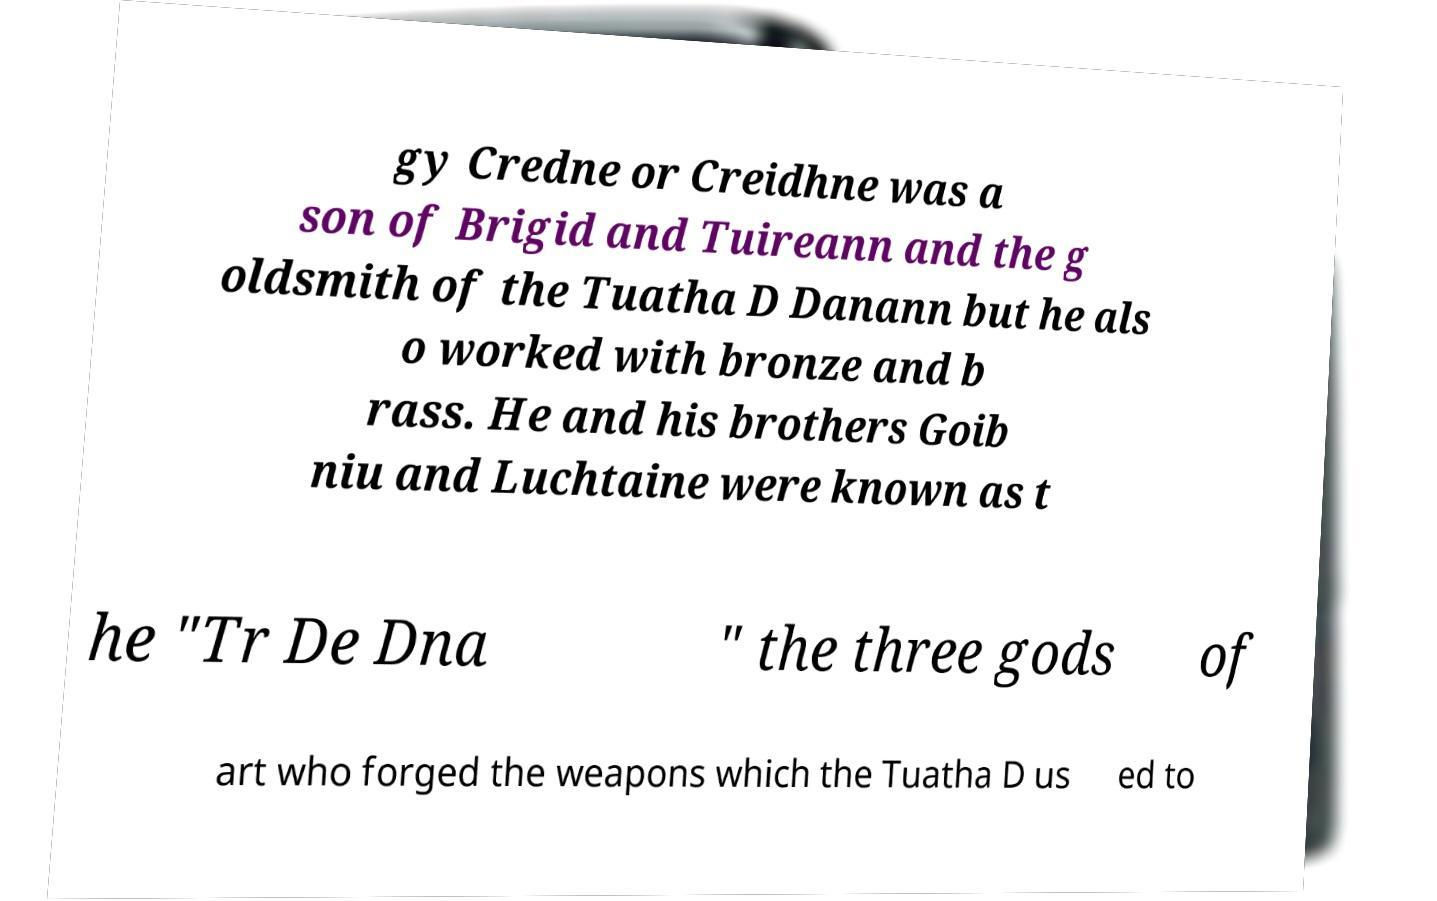There's text embedded in this image that I need extracted. Can you transcribe it verbatim? gy Credne or Creidhne was a son of Brigid and Tuireann and the g oldsmith of the Tuatha D Danann but he als o worked with bronze and b rass. He and his brothers Goib niu and Luchtaine were known as t he "Tr De Dna " the three gods of art who forged the weapons which the Tuatha D us ed to 